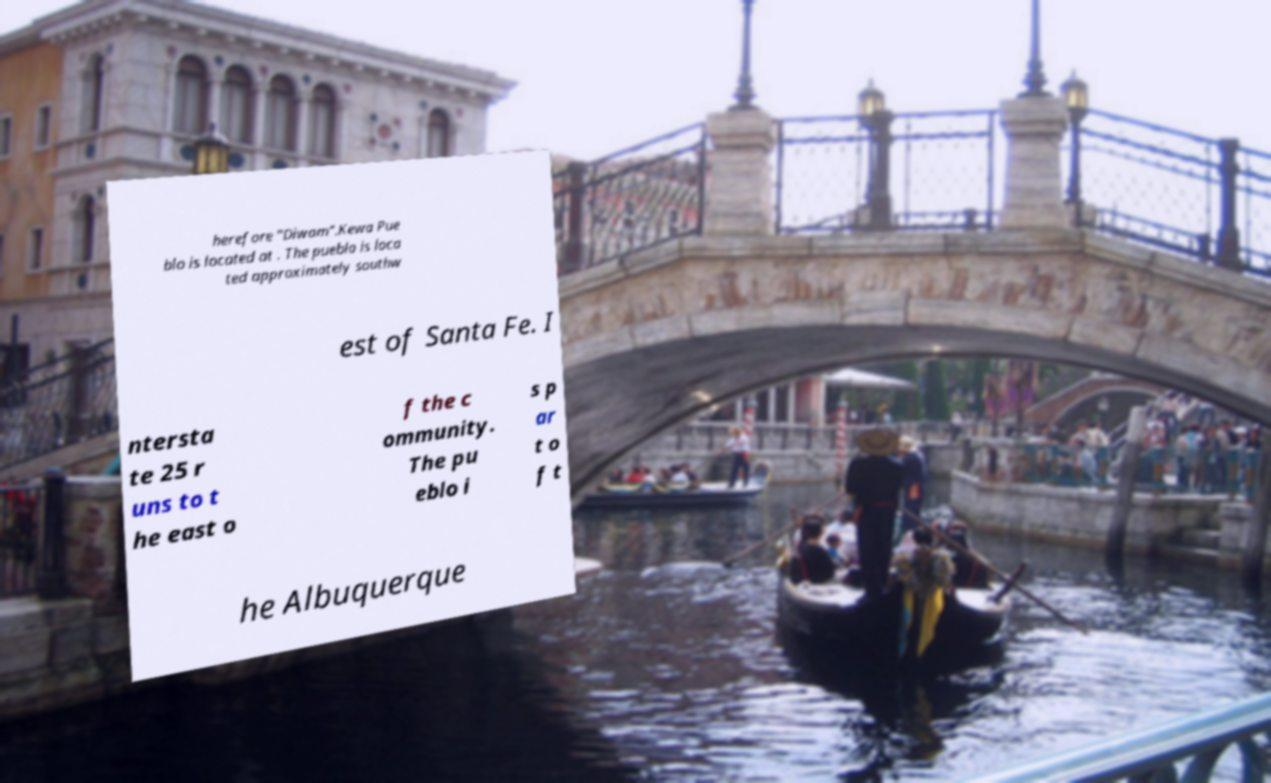Could you assist in decoding the text presented in this image and type it out clearly? herefore "Diwam".Kewa Pue blo is located at . The pueblo is loca ted approximately southw est of Santa Fe. I ntersta te 25 r uns to t he east o f the c ommunity. The pu eblo i s p ar t o f t he Albuquerque 